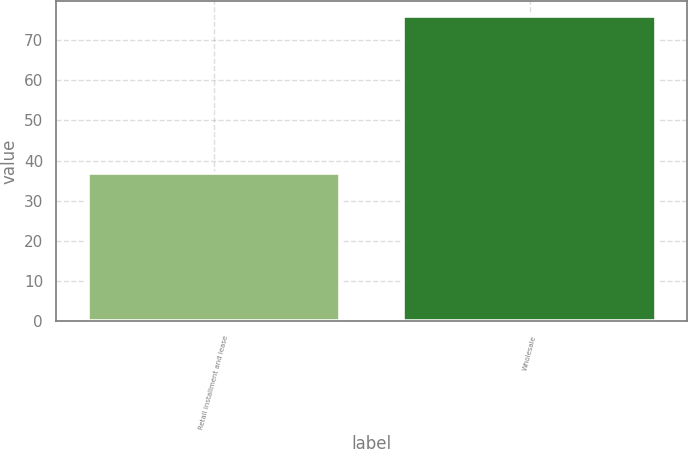<chart> <loc_0><loc_0><loc_500><loc_500><bar_chart><fcel>Retail installment and lease<fcel>Wholesale<nl><fcel>37<fcel>76<nl></chart> 